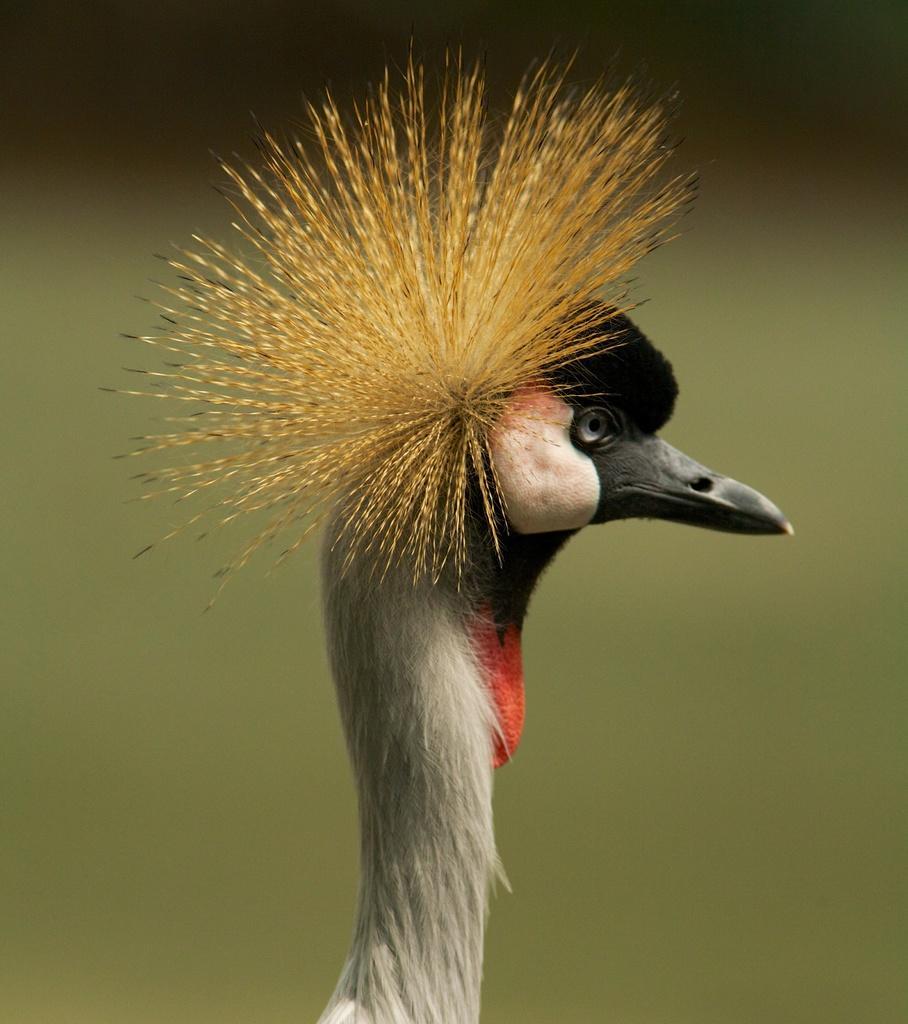Describe this image in one or two sentences. In this picture, we see a flightless bird which has a long neck and a sharp beak. In the background, it is green in color. 